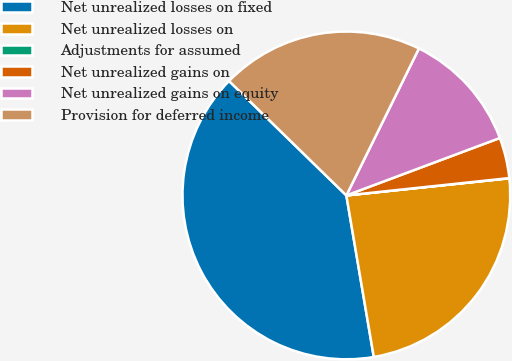Convert chart to OTSL. <chart><loc_0><loc_0><loc_500><loc_500><pie_chart><fcel>Net unrealized losses on fixed<fcel>Net unrealized losses on<fcel>Adjustments for assumed<fcel>Net unrealized gains on<fcel>Net unrealized gains on equity<fcel>Provision for deferred income<nl><fcel>39.98%<fcel>23.99%<fcel>0.02%<fcel>4.01%<fcel>12.0%<fcel>20.0%<nl></chart> 